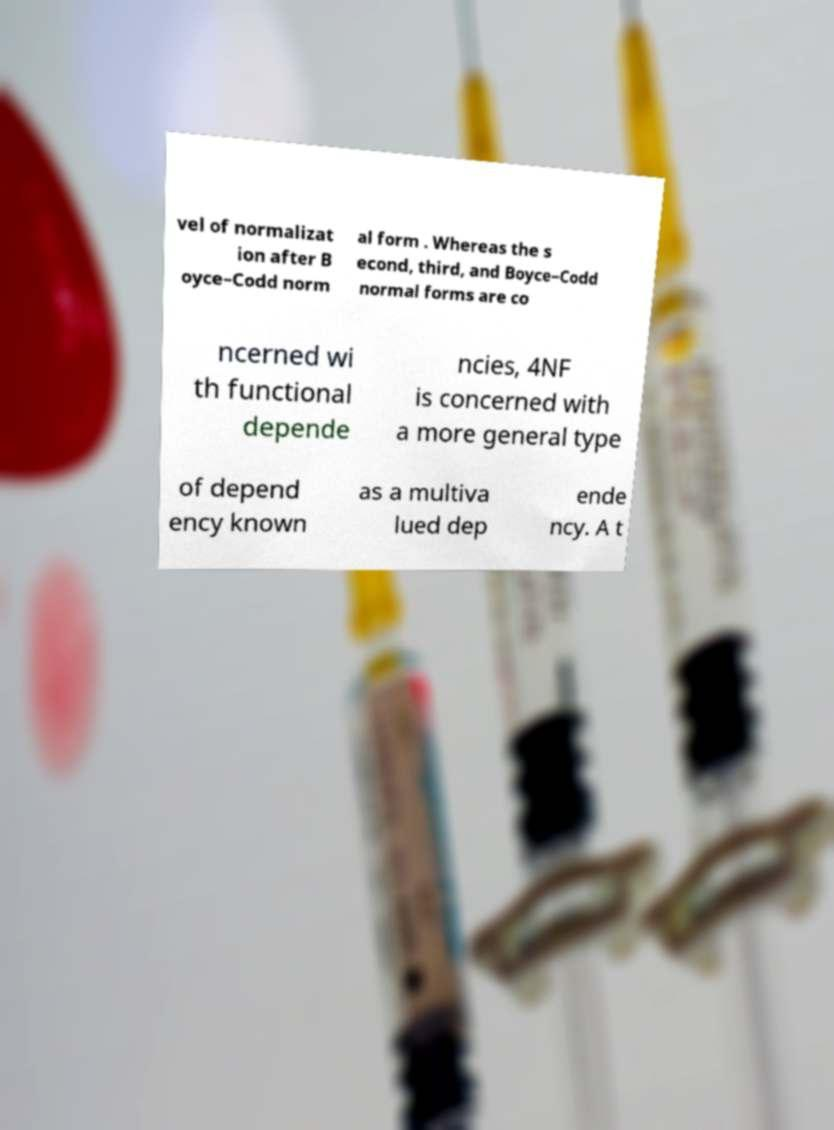Please identify and transcribe the text found in this image. vel of normalizat ion after B oyce–Codd norm al form . Whereas the s econd, third, and Boyce–Codd normal forms are co ncerned wi th functional depende ncies, 4NF is concerned with a more general type of depend ency known as a multiva lued dep ende ncy. A t 